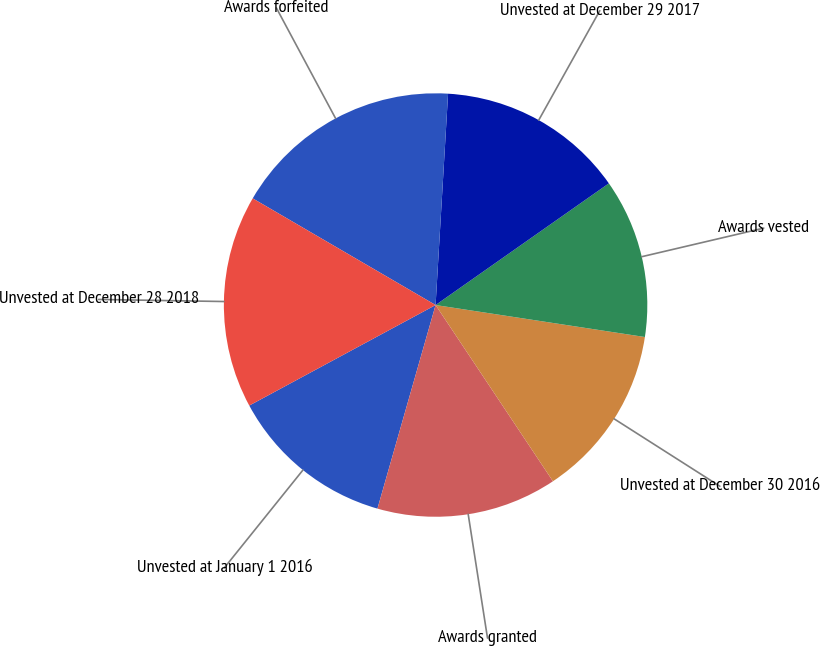Convert chart. <chart><loc_0><loc_0><loc_500><loc_500><pie_chart><fcel>Unvested at January 1 2016<fcel>Awards granted<fcel>Unvested at December 30 2016<fcel>Awards vested<fcel>Unvested at December 29 2017<fcel>Awards forfeited<fcel>Unvested at December 28 2018<nl><fcel>12.7%<fcel>13.78%<fcel>13.24%<fcel>12.16%<fcel>14.32%<fcel>17.54%<fcel>16.28%<nl></chart> 